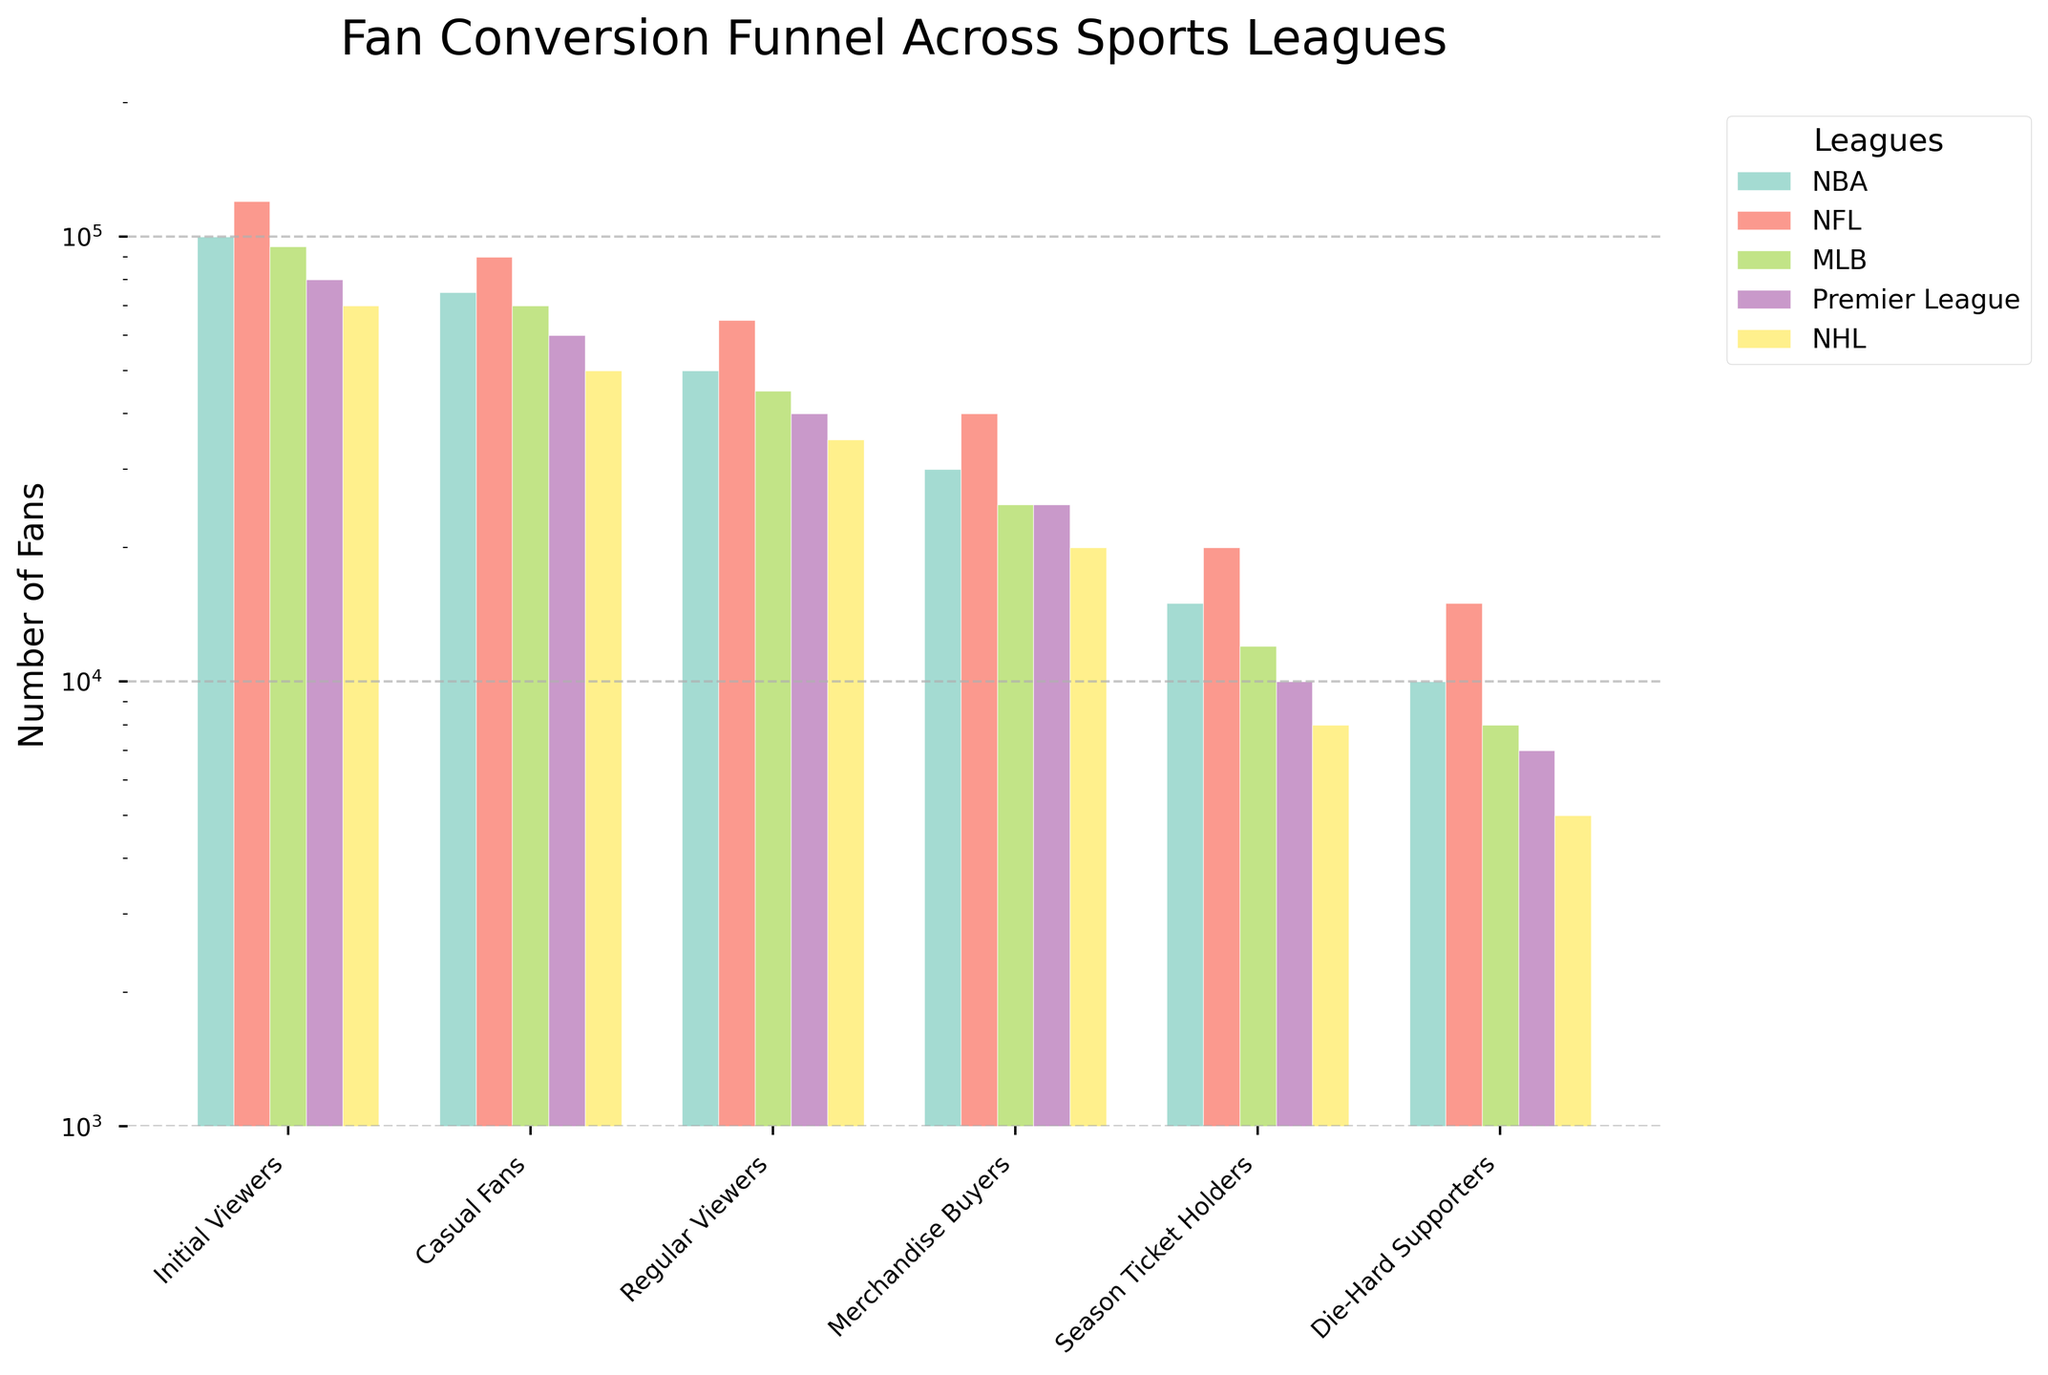What is the title of the chart? The title of the chart is typically found at the top and summarizes what the chart is about, helping the viewer understand the context immediately. In this case, it gives an overview of the conversion of sports fans across different leagues.
Answer: Fan Conversion Funnel Across Sports Leagues What is the y-axis scaling on the chart? By examining the axis, we notice the spacing and numbers, which in this case, indicate a logarithmic scale due to the intervals increasing tenfold.
Answer: Logarithmic Which league has the most Initial Viewers? From the bars representing 'Initial Viewers' for each league using their visual heights, the NFL has the highest bar and thus the most initial viewers.
Answer: NFL By how much do Initial Viewers decrease from 'Initial Viewers' to 'Casual Fans' for the NBA? Subtracting the values presented on the NBA bar from 'Initial Viewers' (100,000) and 'Casual Fans' (75,000) gives the difference. 100,000 - 75,000 = 25,000.
Answer: 25,000 Which league has the lowest number of Die-Hard Supporters? Looking at the bars for 'Die-Hard Supporters,' the NHL bar is the shortest, indicating it has the fewest die-hard supporters.
Answer: NHL Which stage has the narrowest funnel across all leagues combined? Adding values for all leagues at each stage and comparing, Regular Viewers (Sum: 235,000) is relatively narrow compared to Initial Viewers (465,000).
Answer: Regular Viewers Among the leagues, which has the highest conversion rate from Initial Viewers to Die-Hard Supporters? Calculating the ratios, the NFL has 15000/120000 = 12.5%, which is the highest conversion rate compared to other leagues.
Answer: NFL What is the difference in the number of Season Ticket Holders between the NFL and Premier League? Subtracting the values for NFL (20,000) and Premier League (10,000) Season Ticket Holders gives 20,000 - 10,000 = 10,000.
Answer: 10,000 Comparing the number of Merchandise Buyers, which league has the second-highest number? By visual inspection or referring to the values, the NFL has the highest (40,000), and the NBA comes second with 30,000.
Answer: NBA Reflecting on regular viewers, which league shows the smallest drop from Casual Fans to Regular Viewers? Calculating drops, Premier League drops by 60000 - 40000 = 20000, MLB drops by 25000 (least).
Answer: Premier League 